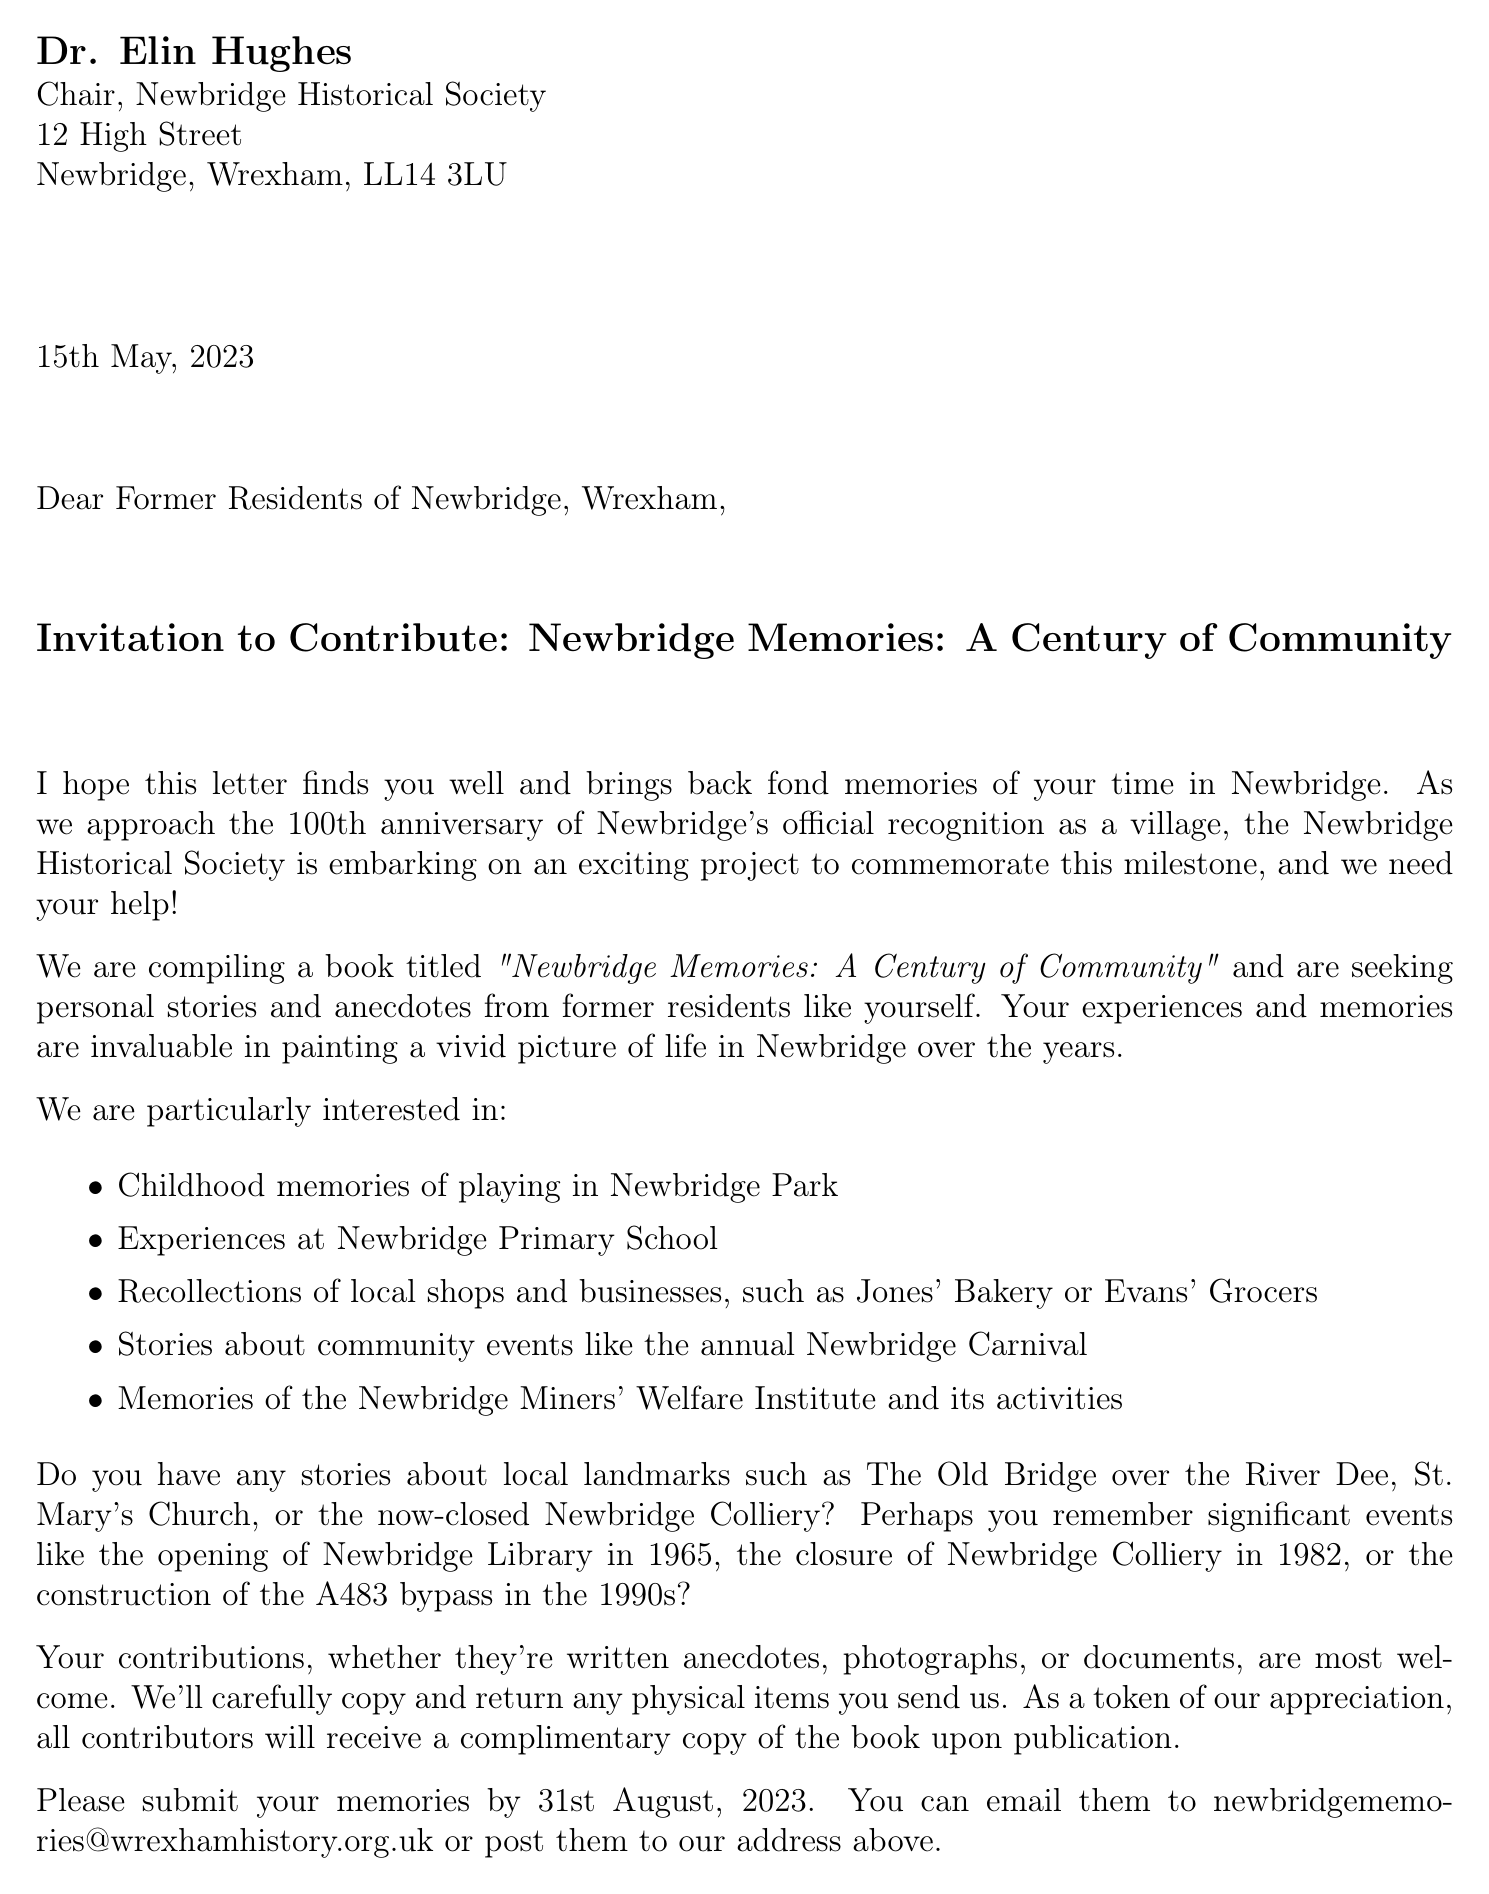What is the sender's name? The sender's name is mentioned at the beginning of the letter and is Dr. Elin Hughes.
Answer: Dr. Elin Hughes What is the book title? The book title is specified in the project description section of the document.
Answer: Newbridge Memories: A Century of Community What is the deadline for submissions? The deadline is stated in the project description for submitting personal stories and anecdotes.
Answer: 31st August, 2023 Where should contributions be sent? The document provides both email and postal address options for submitting contributions.
Answer: newbridgememories@wrexhamhistory.org.uk or 12 High Street, Newbridge, Wrexham, LL14 3LU What community event is mentioned in the letter? The letter lists events that the society is interested in, such as the Newbridge Carnival.
Answer: Newbridge Carnival What significant event took place in 1965? The document refers to historical events, specifying what happened in 1965.
Answer: Opening of Newbridge Library Why is the historical society seeking personal stories? The purpose of collecting personal stories is outlined in the document's introductory section.
Answer: To commemorate the 100th anniversary What will contributors receive? The letter mentions a token of appreciation for contributors upon publication.
Answer: A complimentary copy of the book 